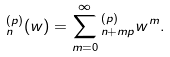Convert formula to latex. <formula><loc_0><loc_0><loc_500><loc_500>\L _ { n } ^ { ( p ) } ( w ) = \sum _ { m = 0 } ^ { \infty } \L _ { n + m p } ^ { ( p ) } w ^ { m } .</formula> 